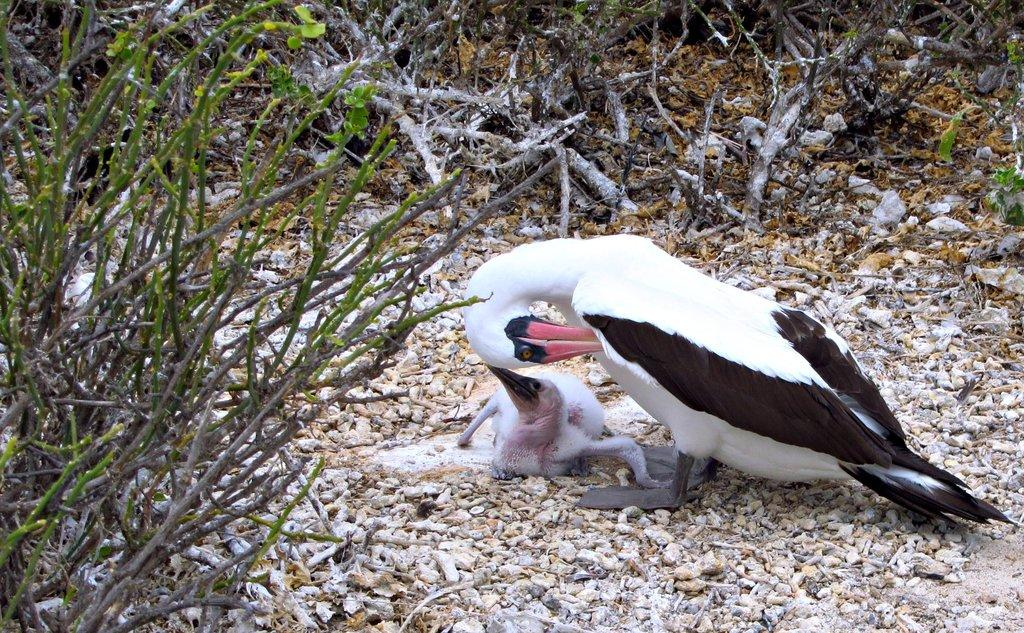What time of day is depicted in the image? The image appears to depict a dusk scene. What can be seen in the foreground of the image? There are ducklings on stones in the foreground of the image. What is present on the left side of the image? There are plants on the left side of the image. What can be seen in the background of the image? The background of the image includes plants. How many pieces of furniture can be seen in the image? There are no pieces of furniture present in the image. What type of dog is visible in the image? There is no dog present in the image. 